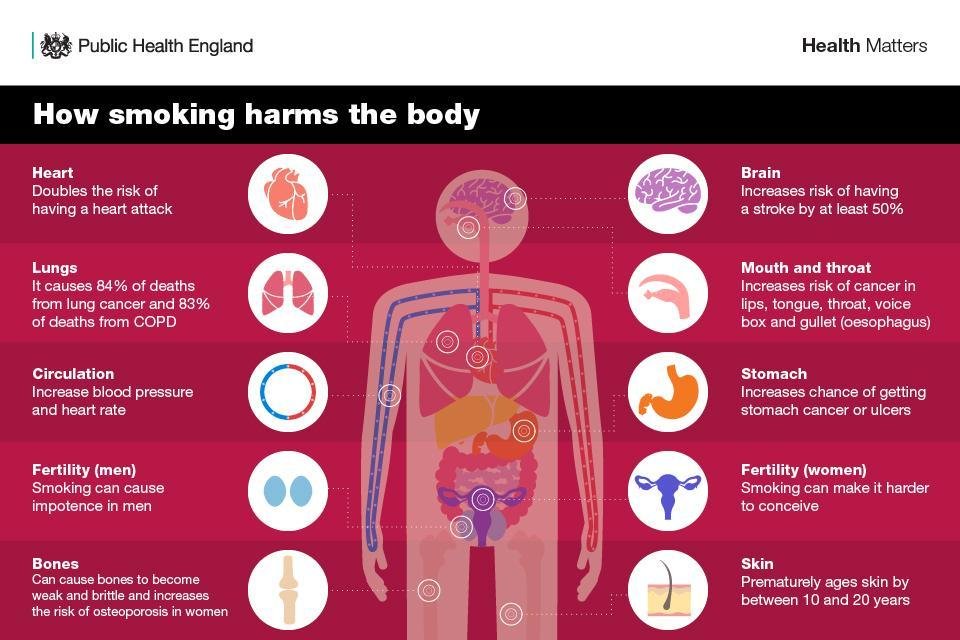What are the two lung diseases caused due to smoking ?
Answer the question with a short phrase. Lung cancer, COPD How many circles are there on either side of the body ? 10 What hinders conception in females ? Smoking What percent of deaths is caused by lung cancer ? 84% What is the colour of the stomach shown in the image - Orange, green or blue ? Orange What is the name of the disease that affects the bones caused due to smoking ? Osteoporosis 